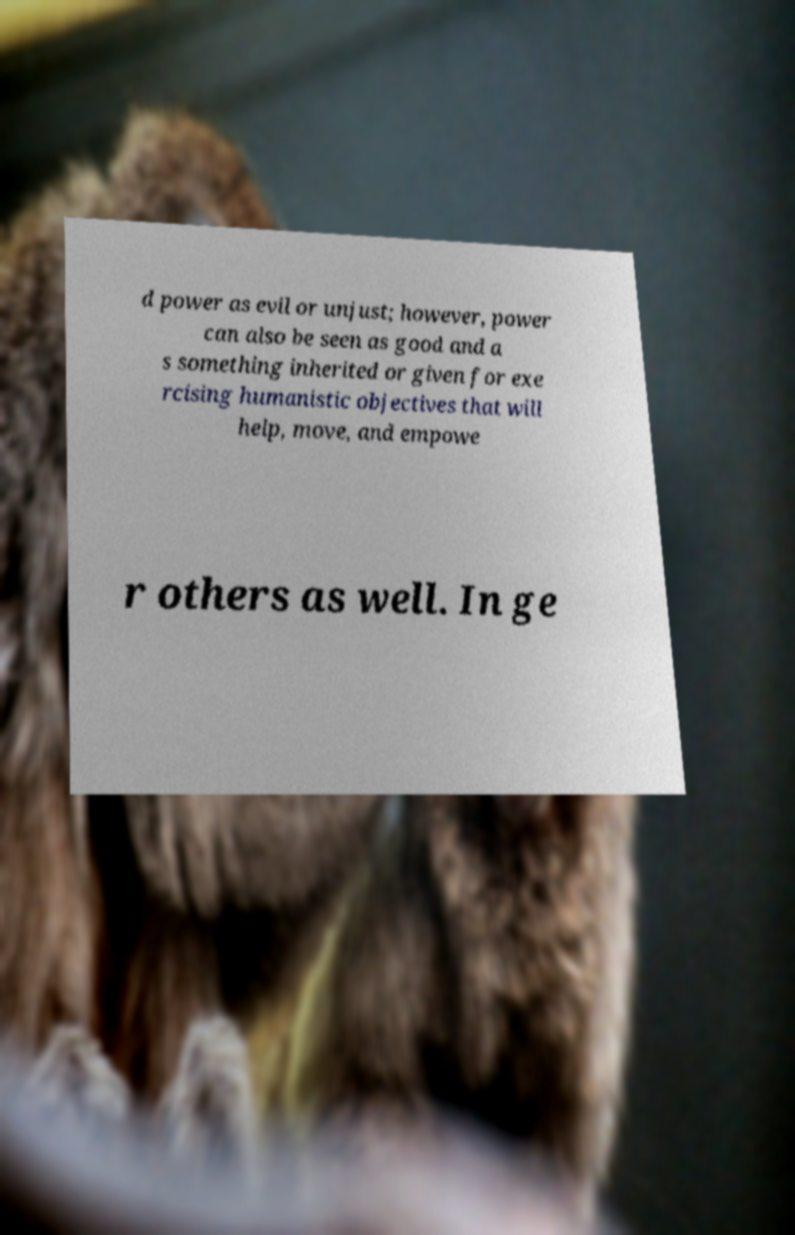Could you extract and type out the text from this image? d power as evil or unjust; however, power can also be seen as good and a s something inherited or given for exe rcising humanistic objectives that will help, move, and empowe r others as well. In ge 